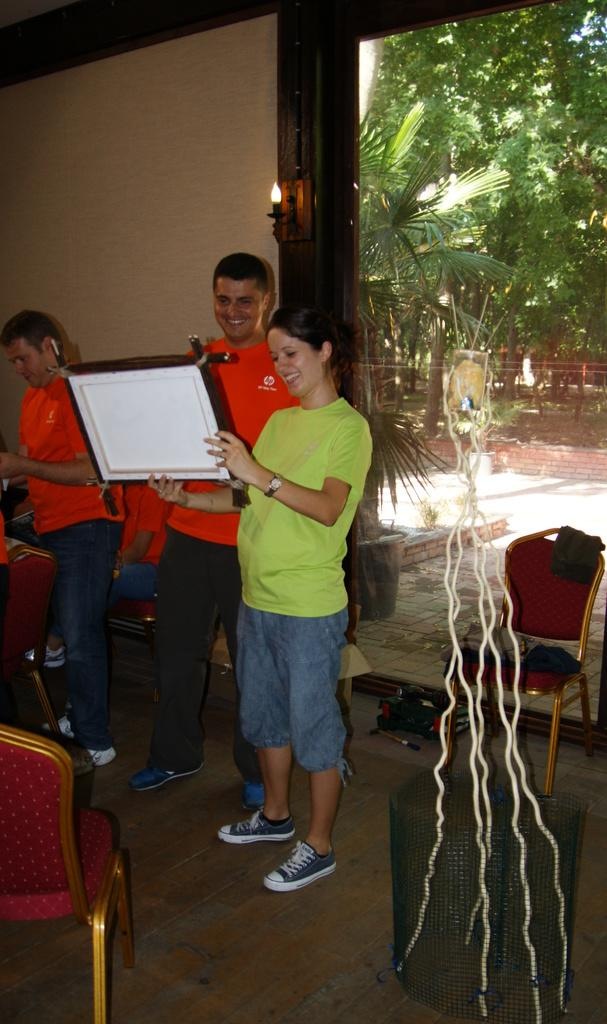What are the people in the image doing? The people in the image are standing. What is the person holding a board doing with it? The person is holding a board. What can be seen in the background of the image? Chairs, a wall, and trees are visible in the background. What type of bead is being used to start a war in the image? There is no mention of a bead or a war in the image; it features people standing and a person holding a board. 